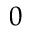<formula> <loc_0><loc_0><loc_500><loc_500>0</formula> 